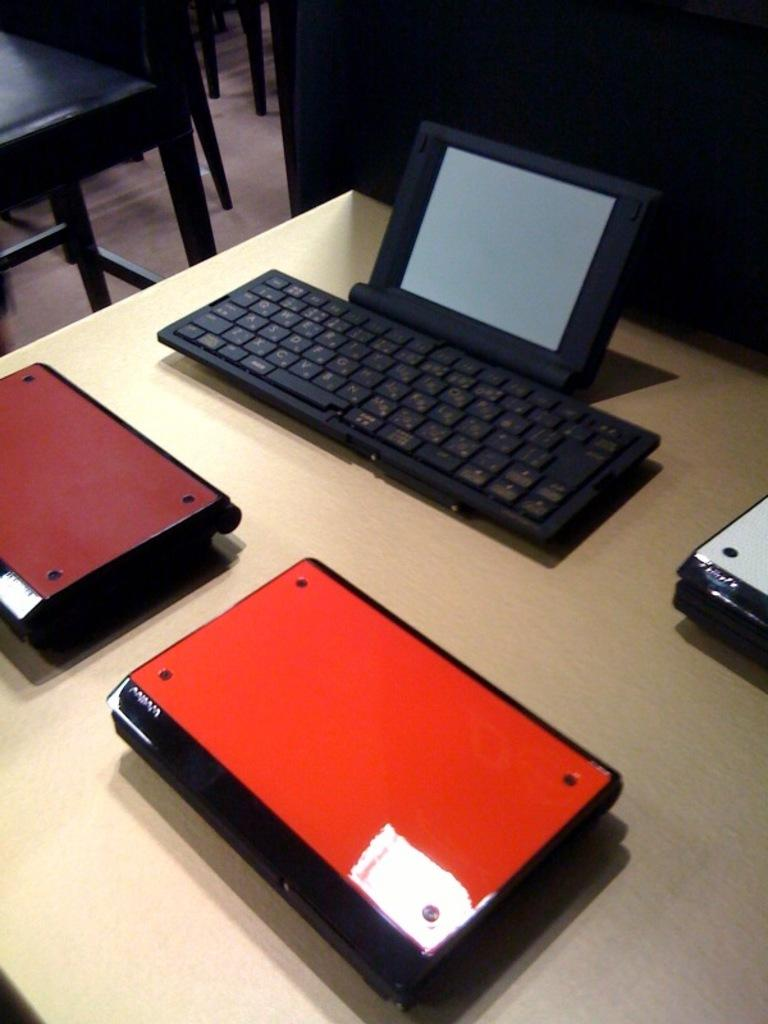What type of device is present in the image? There is a keyboard in the image. What is likely being used with the keyboard? There is a screen in the image, which suggests it might be a computer or laptop. What colors can be seen on the surface in the image? There are maroon, red, white, and black color objects on a cream color surface. What type of furniture is visible in the image? There are chairs visible in the image. What type of tent can be seen in the image? There is no tent present in the image. What type of writing instrument is used with the quill in the image? There is no quill present in the image. 